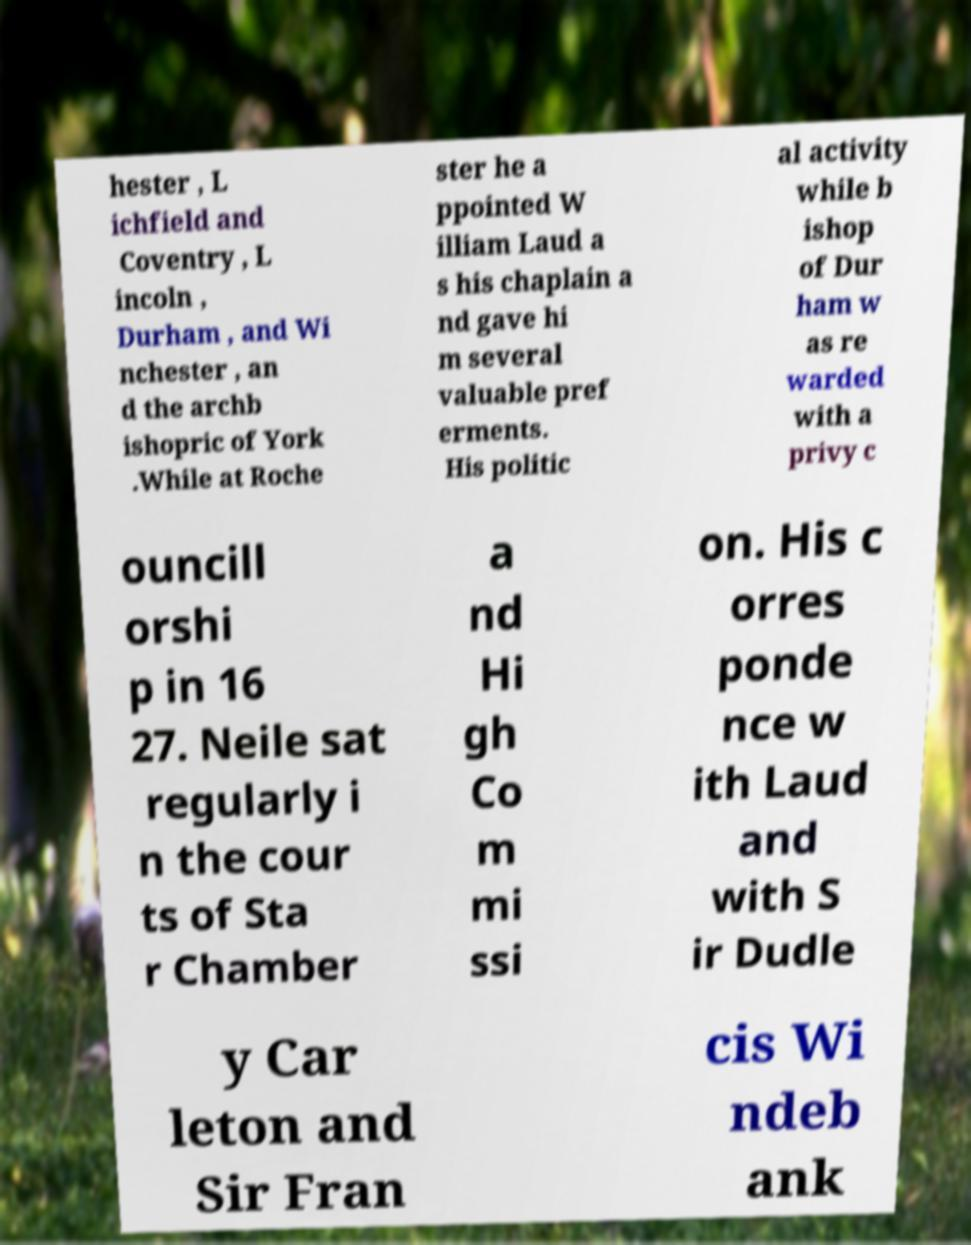Can you accurately transcribe the text from the provided image for me? hester , L ichfield and Coventry , L incoln , Durham , and Wi nchester , an d the archb ishopric of York .While at Roche ster he a ppointed W illiam Laud a s his chaplain a nd gave hi m several valuable pref erments. His politic al activity while b ishop of Dur ham w as re warded with a privy c ouncill orshi p in 16 27. Neile sat regularly i n the cour ts of Sta r Chamber a nd Hi gh Co m mi ssi on. His c orres ponde nce w ith Laud and with S ir Dudle y Car leton and Sir Fran cis Wi ndeb ank 